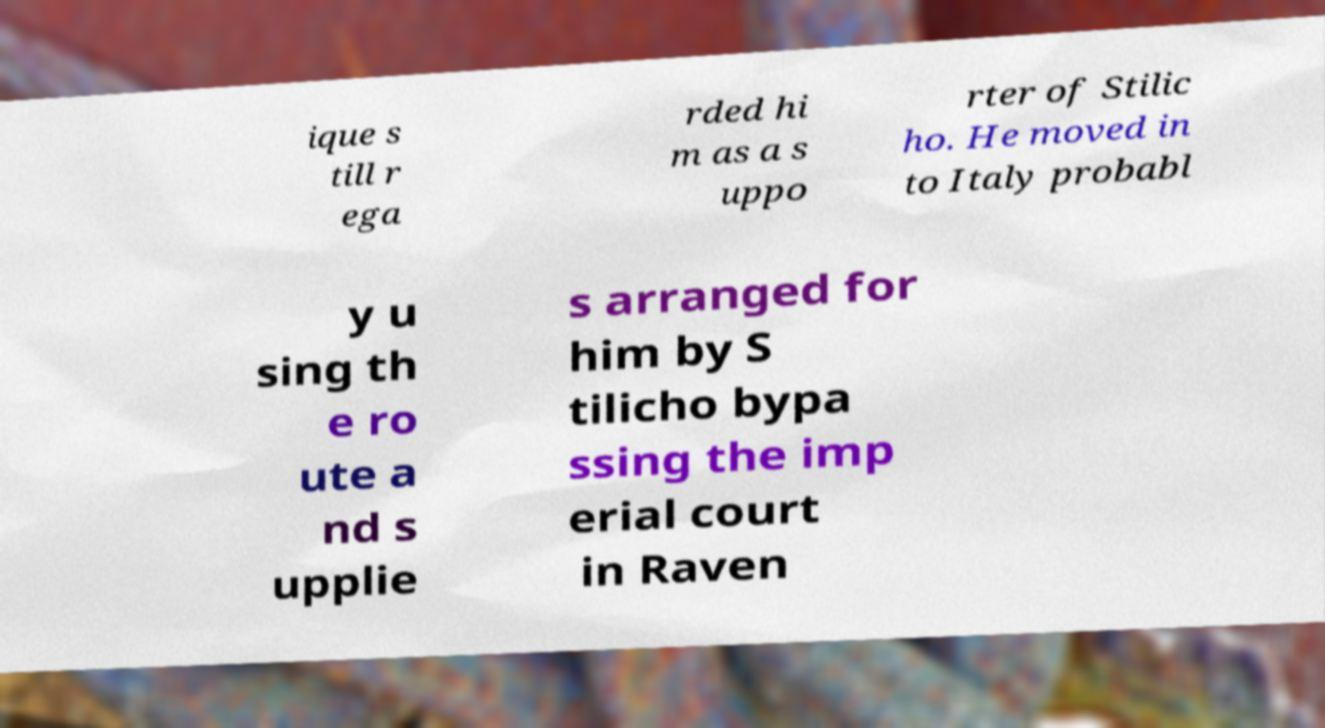Please identify and transcribe the text found in this image. ique s till r ega rded hi m as a s uppo rter of Stilic ho. He moved in to Italy probabl y u sing th e ro ute a nd s upplie s arranged for him by S tilicho bypa ssing the imp erial court in Raven 